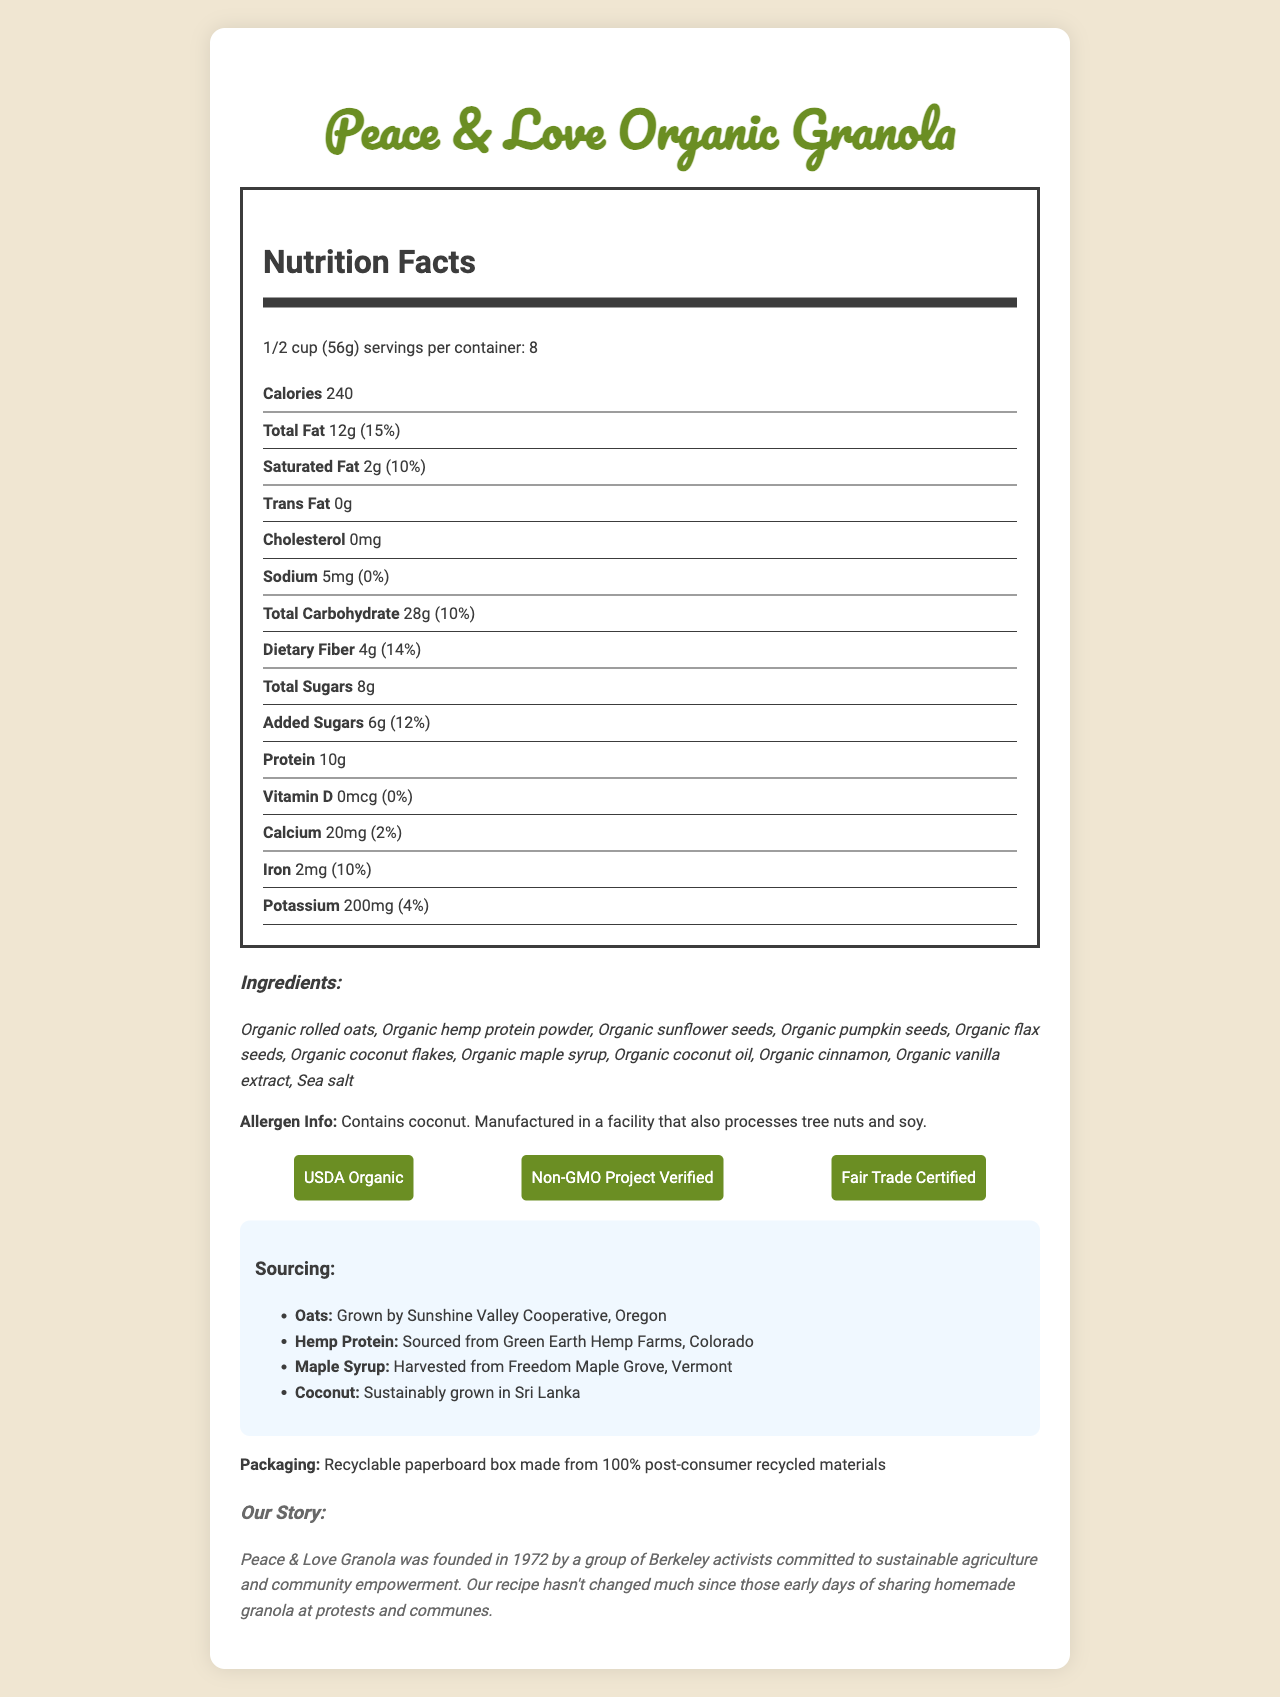what is the serving size of Peace & Love Organic Granola? The serving size is clearly mentioned underneath the product name and in the section "Nutrition Facts" near the beginning of the document.
Answer: 1/2 cup (56g) how many calories are in one serving? The number of calories per serving is explicitly listed in the "Nutrition Facts" section under the "Calories" label.
Answer: 240 what is the total amount of fat per serving? The total fat per serving is listed in the "Nutrition Facts" section under "Total Fat".
Answer: 12g identify two key ingredients in Peace & Love Organic Granola. These ingredients are listed first in the detailed "Ingredients" section.
Answer: Organic rolled oats, Organic hemp protein powder where is the hemp protein sourced from? The sourcing information for the hemp protein is detailed in the "Sourcing" section.
Answer: Green Earth Hemp Farms, Colorado what percentage of the daily value for saturated fat is there per serving? The daily value percentage for saturated fat is shown next to the saturated fat amount in the "Nutrition Facts" section.
Answer: 10% which of the following certifications does this granola have? A. USDA Organic B. Gluten Free C. Fair Trade Certified The certifications listed in the document include USDA Organic and Fair Trade Certified, but not Gluten Free.
Answer: A, C how much protein is in one serving? A. 5g B. 12g C. 10g D. 15g The "Nutrition Facts" section lists 10g of protein per serving.
Answer: C does Peace & Love Organic Granola contain any trans fats? The document states that the trans fat amount is 0g per serving.
Answer: No is the packaging of Peace & Love Organic Granola eco-friendly? The packaging is made from recyclable paperboard and 100% post-consumer recycled materials, as noted in the "Packaging" section.
Answer: Yes summarize the main idea of the document. The document's information covers nutrition facts, ingredients, allergen information, certifications, sourcing of ingredients, eco-friendly packaging, and the brand's origins and story.
Answer: The document provides detailed nutritional information, ingredients, sourcing, certifications, allergen information, and packaging details about Peace & Love Organic Granola, which is an organic, USDA certified, and sustainably sourced product from a brand with historical roots in the 1970s activist community of Berkeley. what year was Peace & Love Granola founded? The year of foundation for Peace & Love Granola is mentioned in the "Brand Story" section.
Answer: 1972 does Peace & Love Organic Granola contain any tree nuts? While it does not explicitly contain tree nuts as an ingredient, the allergen information section states that it is manufactured in a facility that processes tree nuts.
Answer: It is manufactured in a facility that processes tree nuts. which ingredients in Peace & Love Organic Granola are considered seeds? A. Sunflower seeds B. Hemp protein powder C. Pumpkin seeds D. Oats The ingredients list includes sunflower seeds and pumpkin seeds, which are both classified as seeds.
Answer: A, C can individuals with a coconut allergy consume this granola? The allergen information states that the product contains coconut.
Answer: No what is the source of sweetener in Peace & Love Organic Granola? The detailed ingredient list includes organic maple syrup as a sweetener.
Answer: Organic maple syrup who grows the organic rolled oats used in this granola? The sourcing section specifies that the organic rolled oats are grown by Sunshine Valley Cooperative in Oregon.
Answer: Sunshine Valley Cooperative, Oregon how many servings are in one container of Peace & Love Organic Granola? The document states that there are 8 servings per container, noted in the "Nutrition Facts" section.
Answer: 8 what is the granola's fiber content per serving? The dietary fiber content per serving is listed in the "Nutrition Facts" section under "Dietary Fiber".
Answer: 4g how much vitamin D is in each serving? The Vitamin D amount is 0mcg per serving, as noted in the "Nutrition Facts" section.
Answer: 0mcg does the document provide detailed information on the granola’s environmental impact? While the document mentions recyclable packaging and sustainable sourcing, it does not provide a comprehensive assessment of the granola's entire environmental impact.
Answer: Not enough information 